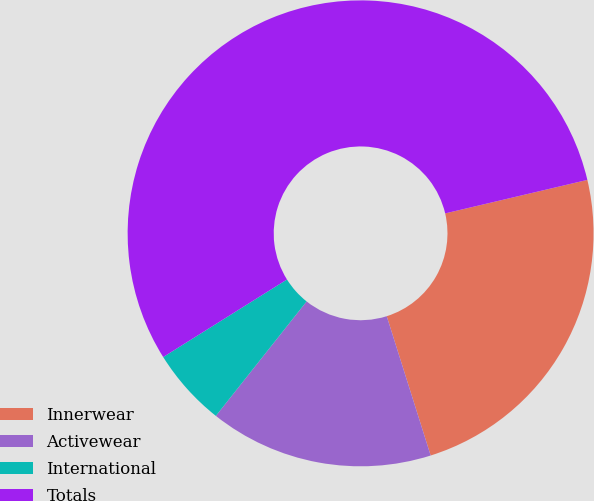<chart> <loc_0><loc_0><loc_500><loc_500><pie_chart><fcel>Innerwear<fcel>Activewear<fcel>International<fcel>Totals<nl><fcel>23.82%<fcel>15.53%<fcel>5.42%<fcel>55.22%<nl></chart> 